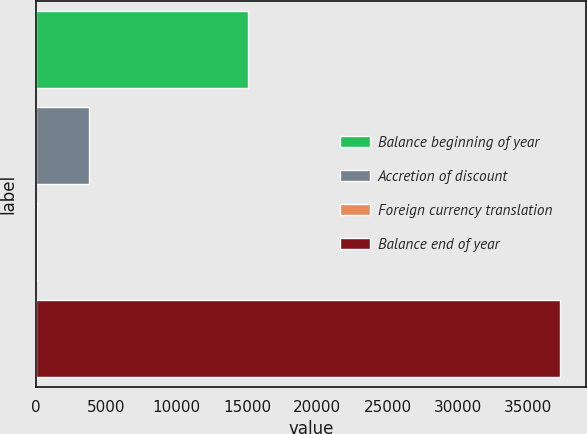Convert chart. <chart><loc_0><loc_0><loc_500><loc_500><bar_chart><fcel>Balance beginning of year<fcel>Accretion of discount<fcel>Foreign currency translation<fcel>Balance end of year<nl><fcel>15085<fcel>3763.5<fcel>45<fcel>37230<nl></chart> 